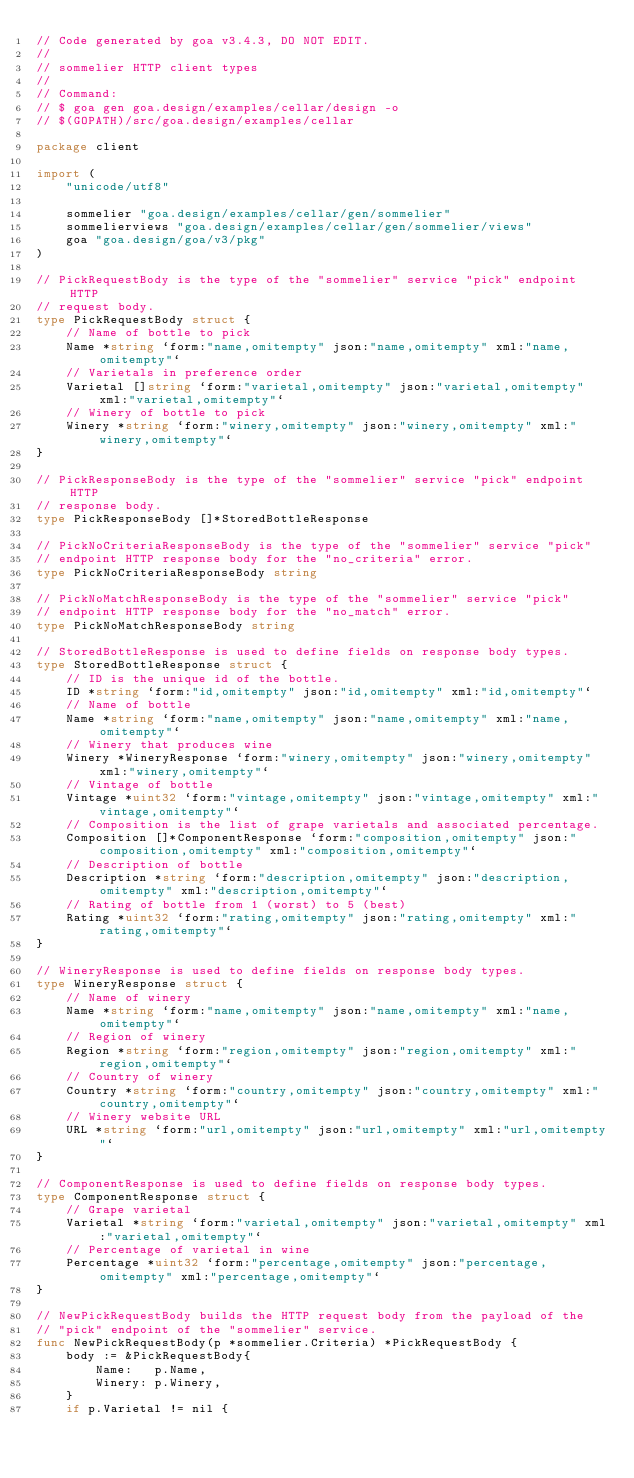Convert code to text. <code><loc_0><loc_0><loc_500><loc_500><_Go_>// Code generated by goa v3.4.3, DO NOT EDIT.
//
// sommelier HTTP client types
//
// Command:
// $ goa gen goa.design/examples/cellar/design -o
// $(GOPATH)/src/goa.design/examples/cellar

package client

import (
	"unicode/utf8"

	sommelier "goa.design/examples/cellar/gen/sommelier"
	sommelierviews "goa.design/examples/cellar/gen/sommelier/views"
	goa "goa.design/goa/v3/pkg"
)

// PickRequestBody is the type of the "sommelier" service "pick" endpoint HTTP
// request body.
type PickRequestBody struct {
	// Name of bottle to pick
	Name *string `form:"name,omitempty" json:"name,omitempty" xml:"name,omitempty"`
	// Varietals in preference order
	Varietal []string `form:"varietal,omitempty" json:"varietal,omitempty" xml:"varietal,omitempty"`
	// Winery of bottle to pick
	Winery *string `form:"winery,omitempty" json:"winery,omitempty" xml:"winery,omitempty"`
}

// PickResponseBody is the type of the "sommelier" service "pick" endpoint HTTP
// response body.
type PickResponseBody []*StoredBottleResponse

// PickNoCriteriaResponseBody is the type of the "sommelier" service "pick"
// endpoint HTTP response body for the "no_criteria" error.
type PickNoCriteriaResponseBody string

// PickNoMatchResponseBody is the type of the "sommelier" service "pick"
// endpoint HTTP response body for the "no_match" error.
type PickNoMatchResponseBody string

// StoredBottleResponse is used to define fields on response body types.
type StoredBottleResponse struct {
	// ID is the unique id of the bottle.
	ID *string `form:"id,omitempty" json:"id,omitempty" xml:"id,omitempty"`
	// Name of bottle
	Name *string `form:"name,omitempty" json:"name,omitempty" xml:"name,omitempty"`
	// Winery that produces wine
	Winery *WineryResponse `form:"winery,omitempty" json:"winery,omitempty" xml:"winery,omitempty"`
	// Vintage of bottle
	Vintage *uint32 `form:"vintage,omitempty" json:"vintage,omitempty" xml:"vintage,omitempty"`
	// Composition is the list of grape varietals and associated percentage.
	Composition []*ComponentResponse `form:"composition,omitempty" json:"composition,omitempty" xml:"composition,omitempty"`
	// Description of bottle
	Description *string `form:"description,omitempty" json:"description,omitempty" xml:"description,omitempty"`
	// Rating of bottle from 1 (worst) to 5 (best)
	Rating *uint32 `form:"rating,omitempty" json:"rating,omitempty" xml:"rating,omitempty"`
}

// WineryResponse is used to define fields on response body types.
type WineryResponse struct {
	// Name of winery
	Name *string `form:"name,omitempty" json:"name,omitempty" xml:"name,omitempty"`
	// Region of winery
	Region *string `form:"region,omitempty" json:"region,omitempty" xml:"region,omitempty"`
	// Country of winery
	Country *string `form:"country,omitempty" json:"country,omitempty" xml:"country,omitempty"`
	// Winery website URL
	URL *string `form:"url,omitempty" json:"url,omitempty" xml:"url,omitempty"`
}

// ComponentResponse is used to define fields on response body types.
type ComponentResponse struct {
	// Grape varietal
	Varietal *string `form:"varietal,omitempty" json:"varietal,omitempty" xml:"varietal,omitempty"`
	// Percentage of varietal in wine
	Percentage *uint32 `form:"percentage,omitempty" json:"percentage,omitempty" xml:"percentage,omitempty"`
}

// NewPickRequestBody builds the HTTP request body from the payload of the
// "pick" endpoint of the "sommelier" service.
func NewPickRequestBody(p *sommelier.Criteria) *PickRequestBody {
	body := &PickRequestBody{
		Name:   p.Name,
		Winery: p.Winery,
	}
	if p.Varietal != nil {</code> 